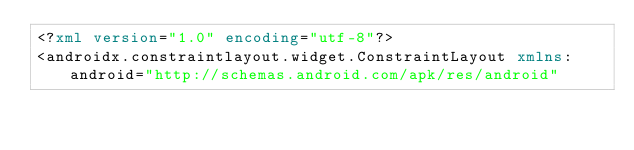Convert code to text. <code><loc_0><loc_0><loc_500><loc_500><_XML_><?xml version="1.0" encoding="utf-8"?>
<androidx.constraintlayout.widget.ConstraintLayout xmlns:android="http://schemas.android.com/apk/res/android"</code> 